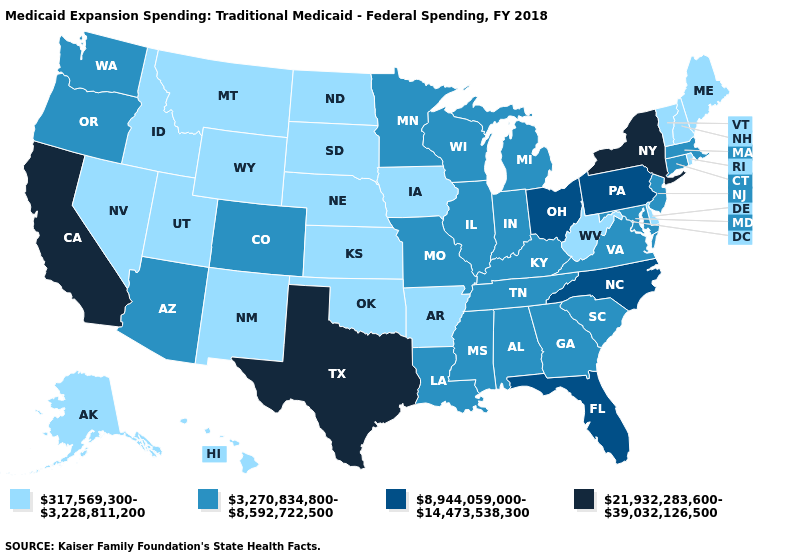What is the lowest value in the USA?
Keep it brief. 317,569,300-3,228,811,200. Does the first symbol in the legend represent the smallest category?
Give a very brief answer. Yes. Does Arkansas have the same value as Connecticut?
Give a very brief answer. No. What is the value of Texas?
Give a very brief answer. 21,932,283,600-39,032,126,500. Among the states that border Mississippi , which have the lowest value?
Give a very brief answer. Arkansas. What is the value of Alabama?
Keep it brief. 3,270,834,800-8,592,722,500. Does South Carolina have the same value as Missouri?
Concise answer only. Yes. Among the states that border North Dakota , does Minnesota have the lowest value?
Short answer required. No. Name the states that have a value in the range 317,569,300-3,228,811,200?
Short answer required. Alaska, Arkansas, Delaware, Hawaii, Idaho, Iowa, Kansas, Maine, Montana, Nebraska, Nevada, New Hampshire, New Mexico, North Dakota, Oklahoma, Rhode Island, South Dakota, Utah, Vermont, West Virginia, Wyoming. Name the states that have a value in the range 317,569,300-3,228,811,200?
Short answer required. Alaska, Arkansas, Delaware, Hawaii, Idaho, Iowa, Kansas, Maine, Montana, Nebraska, Nevada, New Hampshire, New Mexico, North Dakota, Oklahoma, Rhode Island, South Dakota, Utah, Vermont, West Virginia, Wyoming. Does New Hampshire have a lower value than Nevada?
Write a very short answer. No. Name the states that have a value in the range 317,569,300-3,228,811,200?
Answer briefly. Alaska, Arkansas, Delaware, Hawaii, Idaho, Iowa, Kansas, Maine, Montana, Nebraska, Nevada, New Hampshire, New Mexico, North Dakota, Oklahoma, Rhode Island, South Dakota, Utah, Vermont, West Virginia, Wyoming. Which states have the highest value in the USA?
Short answer required. California, New York, Texas. Name the states that have a value in the range 317,569,300-3,228,811,200?
Keep it brief. Alaska, Arkansas, Delaware, Hawaii, Idaho, Iowa, Kansas, Maine, Montana, Nebraska, Nevada, New Hampshire, New Mexico, North Dakota, Oklahoma, Rhode Island, South Dakota, Utah, Vermont, West Virginia, Wyoming. 